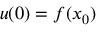Convert formula to latex. <formula><loc_0><loc_0><loc_500><loc_500>u ( 0 ) = f ( x _ { 0 } )</formula> 